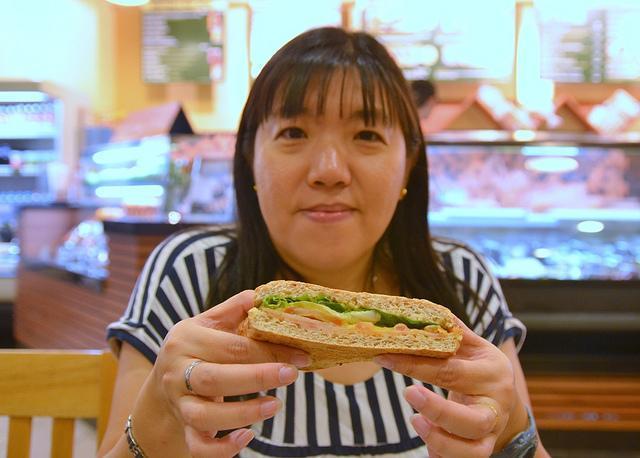Does the description: "The person is touching the sandwich." accurately reflect the image?
Answer yes or no. Yes. 